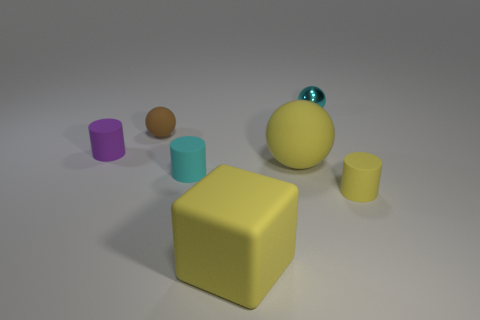Do the cyan thing that is left of the metal object and the purple thing to the left of the block have the same shape?
Your response must be concise. Yes. What number of things are either blue cubes or yellow matte things behind the big yellow matte block?
Your answer should be compact. 2. What is the material of the tiny cylinder that is on the right side of the tiny brown object and on the left side of the small metallic ball?
Your response must be concise. Rubber. Is there anything else that is the same shape as the purple matte thing?
Offer a terse response. Yes. What color is the large cube that is made of the same material as the purple cylinder?
Offer a terse response. Yellow. What number of things are either small gray shiny cylinders or small cyan matte cylinders?
Your response must be concise. 1. There is a yellow rubber sphere; is its size the same as the yellow object that is on the left side of the big matte ball?
Offer a terse response. Yes. There is a small cylinder that is right of the tiny cyan object behind the tiny ball that is to the left of the small cyan metallic sphere; what color is it?
Provide a short and direct response. Yellow. What is the color of the tiny rubber sphere?
Give a very brief answer. Brown. Is the number of tiny things that are left of the matte cube greater than the number of small purple matte cylinders on the left side of the purple matte cylinder?
Offer a very short reply. Yes. 